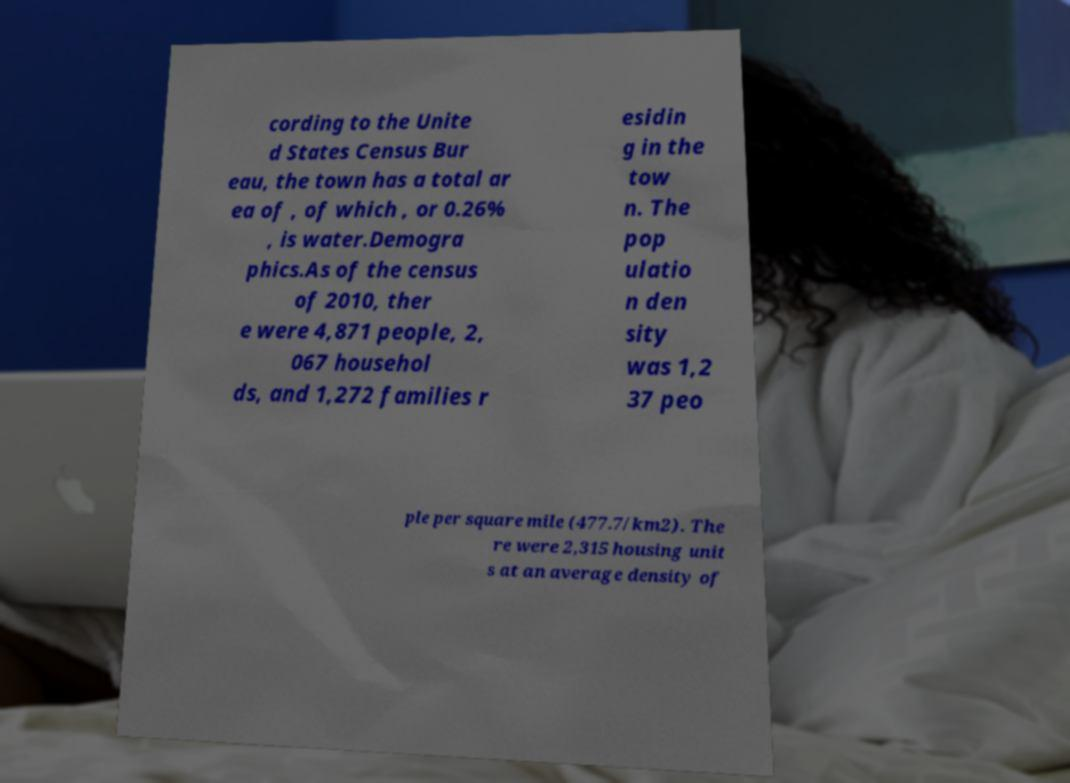Could you extract and type out the text from this image? cording to the Unite d States Census Bur eau, the town has a total ar ea of , of which , or 0.26% , is water.Demogra phics.As of the census of 2010, ther e were 4,871 people, 2, 067 househol ds, and 1,272 families r esidin g in the tow n. The pop ulatio n den sity was 1,2 37 peo ple per square mile (477.7/km2). The re were 2,315 housing unit s at an average density of 